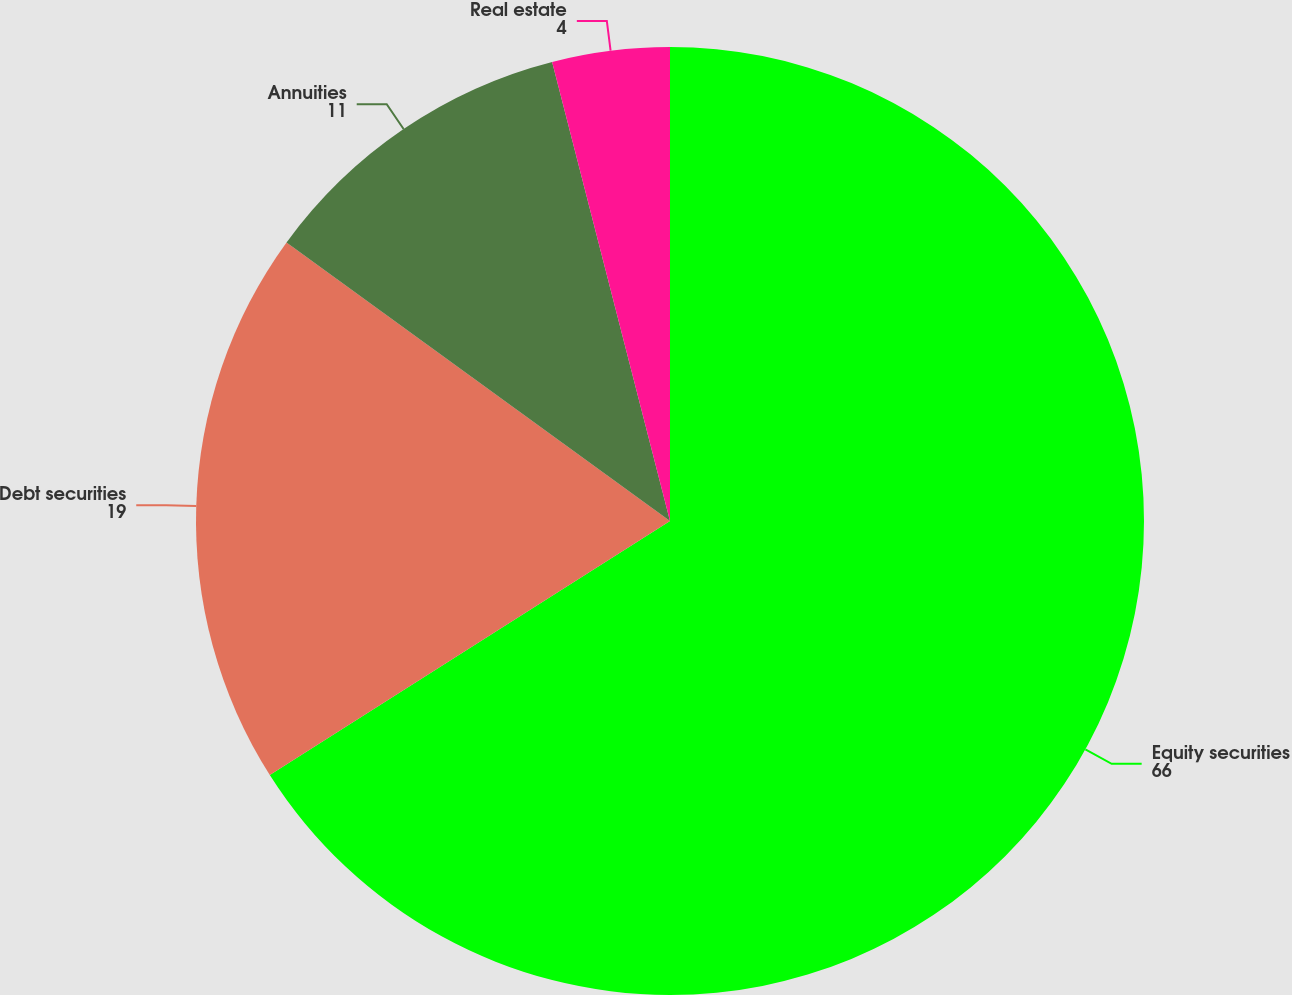Convert chart to OTSL. <chart><loc_0><loc_0><loc_500><loc_500><pie_chart><fcel>Equity securities<fcel>Debt securities<fcel>Annuities<fcel>Real estate<nl><fcel>66.0%<fcel>19.0%<fcel>11.0%<fcel>4.0%<nl></chart> 